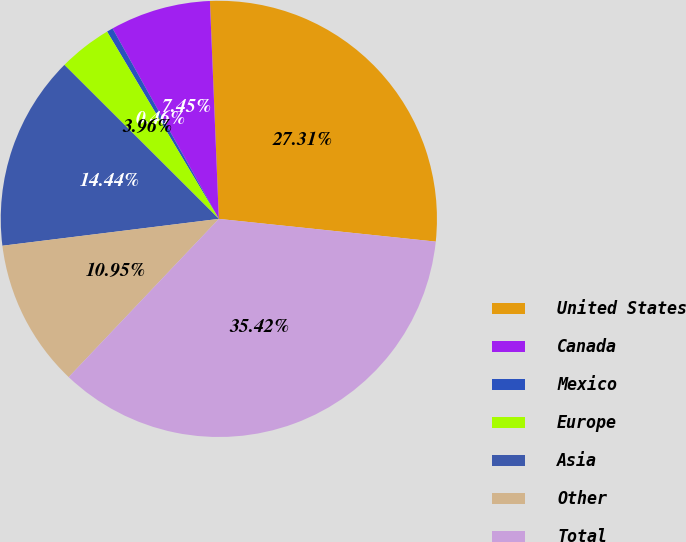<chart> <loc_0><loc_0><loc_500><loc_500><pie_chart><fcel>United States<fcel>Canada<fcel>Mexico<fcel>Europe<fcel>Asia<fcel>Other<fcel>Total<nl><fcel>27.31%<fcel>7.45%<fcel>0.46%<fcel>3.96%<fcel>14.44%<fcel>10.95%<fcel>35.42%<nl></chart> 